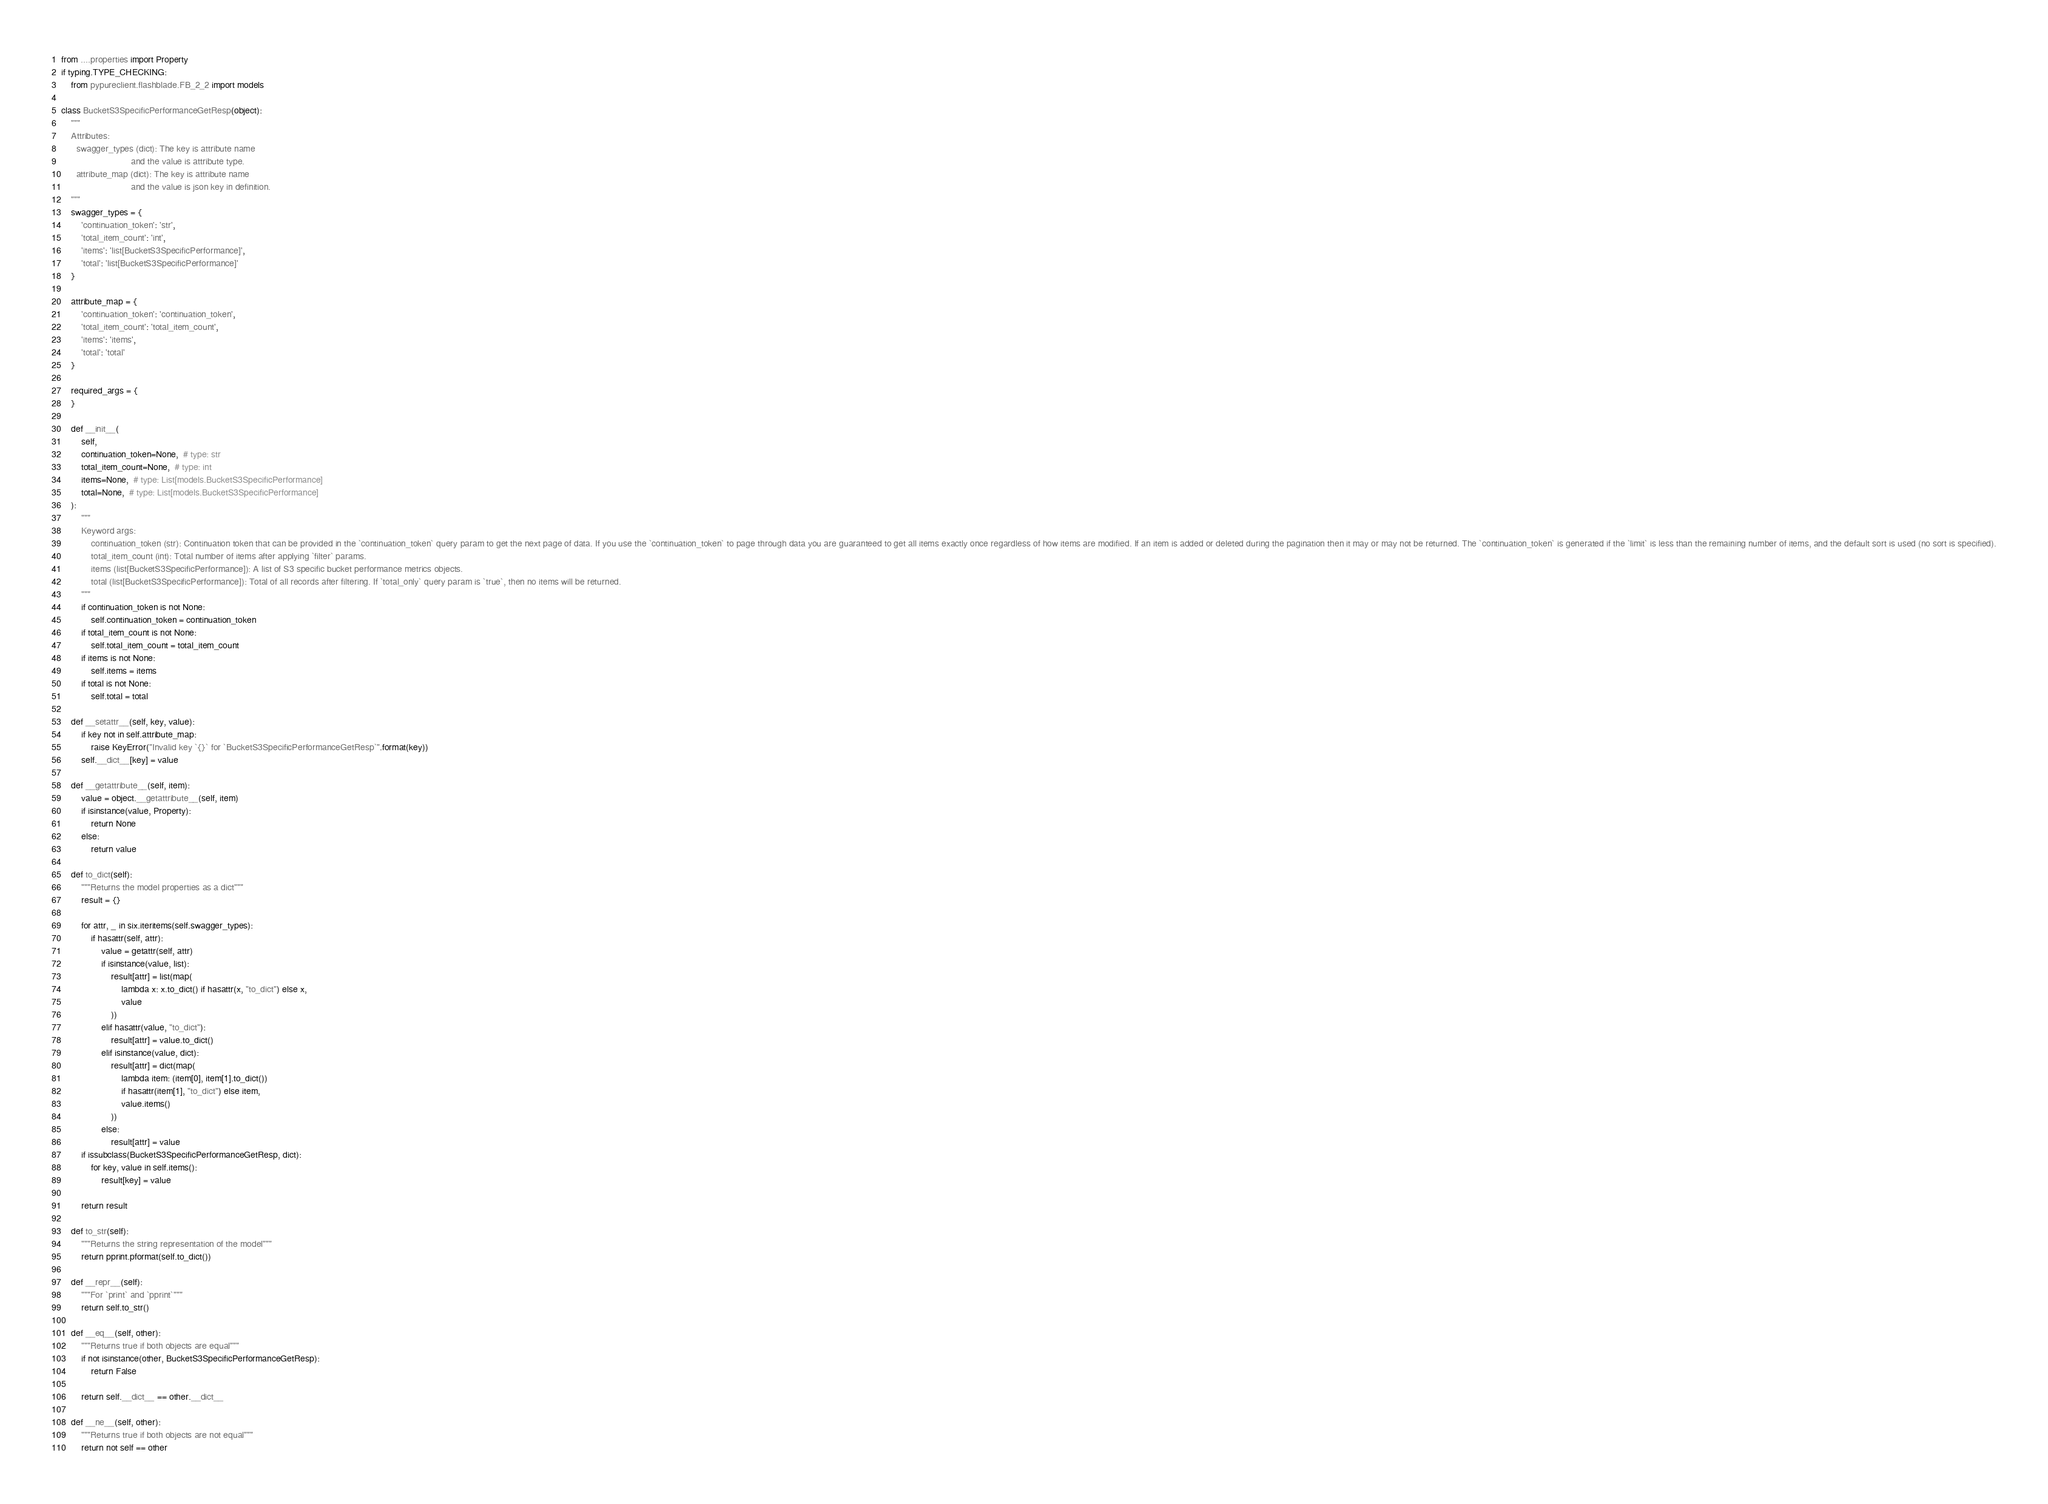<code> <loc_0><loc_0><loc_500><loc_500><_Python_>from ....properties import Property
if typing.TYPE_CHECKING:
    from pypureclient.flashblade.FB_2_2 import models

class BucketS3SpecificPerformanceGetResp(object):
    """
    Attributes:
      swagger_types (dict): The key is attribute name
                            and the value is attribute type.
      attribute_map (dict): The key is attribute name
                            and the value is json key in definition.
    """
    swagger_types = {
        'continuation_token': 'str',
        'total_item_count': 'int',
        'items': 'list[BucketS3SpecificPerformance]',
        'total': 'list[BucketS3SpecificPerformance]'
    }

    attribute_map = {
        'continuation_token': 'continuation_token',
        'total_item_count': 'total_item_count',
        'items': 'items',
        'total': 'total'
    }

    required_args = {
    }

    def __init__(
        self,
        continuation_token=None,  # type: str
        total_item_count=None,  # type: int
        items=None,  # type: List[models.BucketS3SpecificPerformance]
        total=None,  # type: List[models.BucketS3SpecificPerformance]
    ):
        """
        Keyword args:
            continuation_token (str): Continuation token that can be provided in the `continuation_token` query param to get the next page of data. If you use the `continuation_token` to page through data you are guaranteed to get all items exactly once regardless of how items are modified. If an item is added or deleted during the pagination then it may or may not be returned. The `continuation_token` is generated if the `limit` is less than the remaining number of items, and the default sort is used (no sort is specified).
            total_item_count (int): Total number of items after applying `filter` params.
            items (list[BucketS3SpecificPerformance]): A list of S3 specific bucket performance metrics objects.
            total (list[BucketS3SpecificPerformance]): Total of all records after filtering. If `total_only` query param is `true`, then no items will be returned.
        """
        if continuation_token is not None:
            self.continuation_token = continuation_token
        if total_item_count is not None:
            self.total_item_count = total_item_count
        if items is not None:
            self.items = items
        if total is not None:
            self.total = total

    def __setattr__(self, key, value):
        if key not in self.attribute_map:
            raise KeyError("Invalid key `{}` for `BucketS3SpecificPerformanceGetResp`".format(key))
        self.__dict__[key] = value

    def __getattribute__(self, item):
        value = object.__getattribute__(self, item)
        if isinstance(value, Property):
            return None
        else:
            return value

    def to_dict(self):
        """Returns the model properties as a dict"""
        result = {}

        for attr, _ in six.iteritems(self.swagger_types):
            if hasattr(self, attr):
                value = getattr(self, attr)
                if isinstance(value, list):
                    result[attr] = list(map(
                        lambda x: x.to_dict() if hasattr(x, "to_dict") else x,
                        value
                    ))
                elif hasattr(value, "to_dict"):
                    result[attr] = value.to_dict()
                elif isinstance(value, dict):
                    result[attr] = dict(map(
                        lambda item: (item[0], item[1].to_dict())
                        if hasattr(item[1], "to_dict") else item,
                        value.items()
                    ))
                else:
                    result[attr] = value
        if issubclass(BucketS3SpecificPerformanceGetResp, dict):
            for key, value in self.items():
                result[key] = value

        return result

    def to_str(self):
        """Returns the string representation of the model"""
        return pprint.pformat(self.to_dict())

    def __repr__(self):
        """For `print` and `pprint`"""
        return self.to_str()

    def __eq__(self, other):
        """Returns true if both objects are equal"""
        if not isinstance(other, BucketS3SpecificPerformanceGetResp):
            return False

        return self.__dict__ == other.__dict__

    def __ne__(self, other):
        """Returns true if both objects are not equal"""
        return not self == other
</code> 